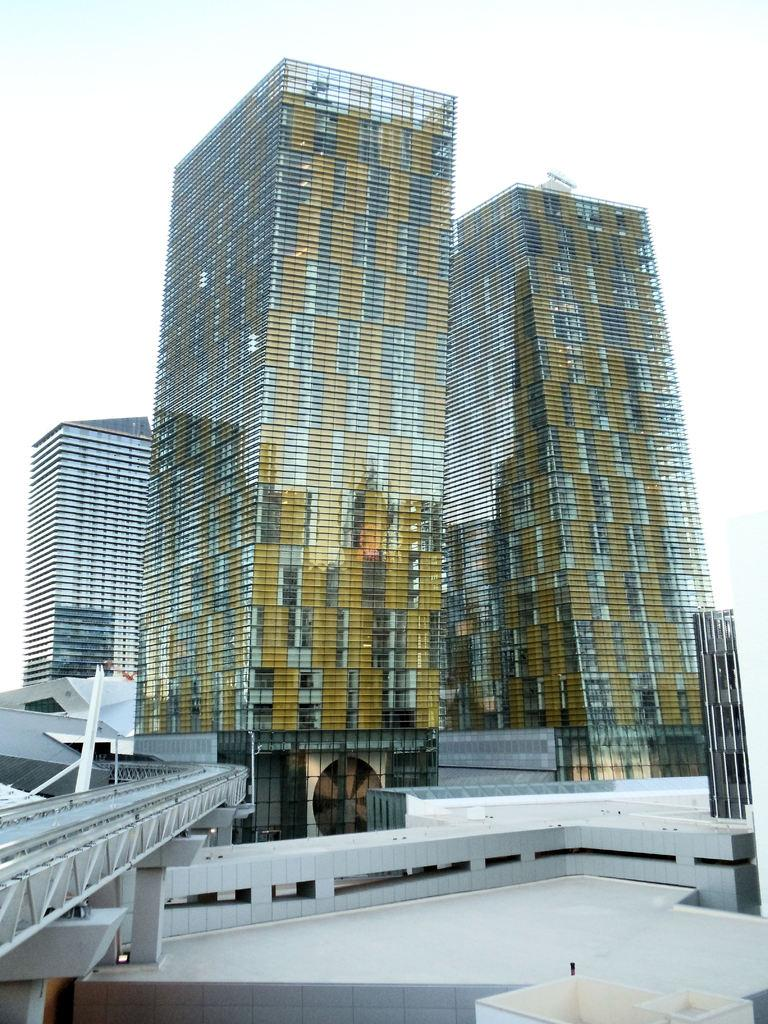Where was the picture taken? The picture was clicked outside. What is the main subject in the foreground of the image? There is a bridge in the foreground of the image. What else can be seen in the foreground of the image? There are objects in the foreground of the image. What is located in the center of the image? There are buildings in the center of the image. What can be seen in the background of the image? There is a sky visible in the background of the image. What story is being told by the lock on the bridge in the image? There is no lock present on the bridge in the image, so no story can be told based on it. 